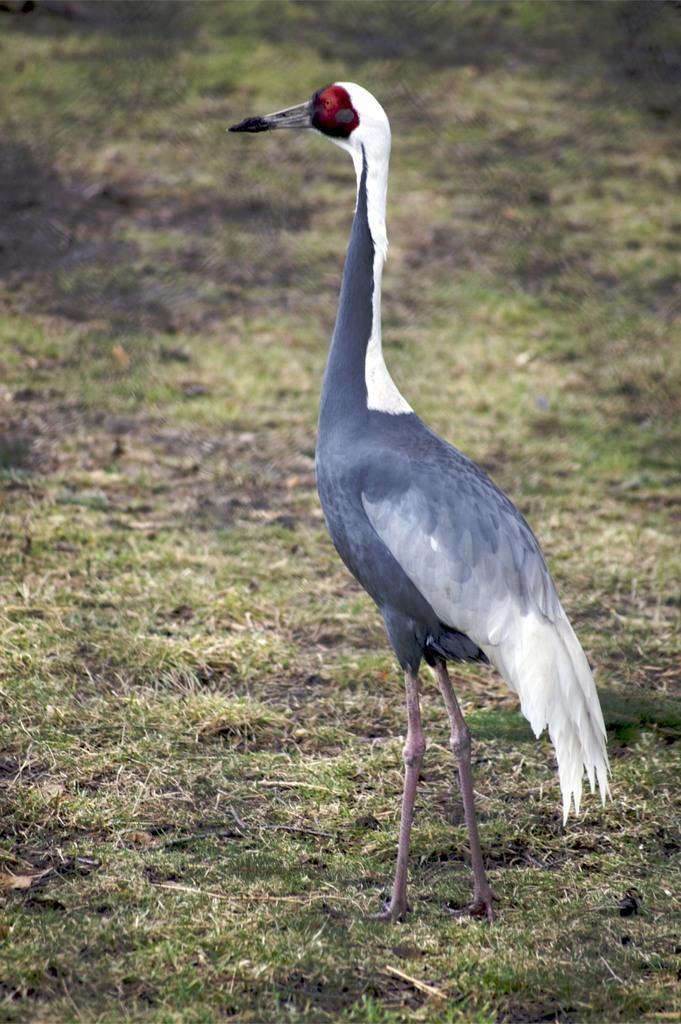Describe this image in one or two sentences. In this picture we can see a crane here, at the bottom there is grass. 